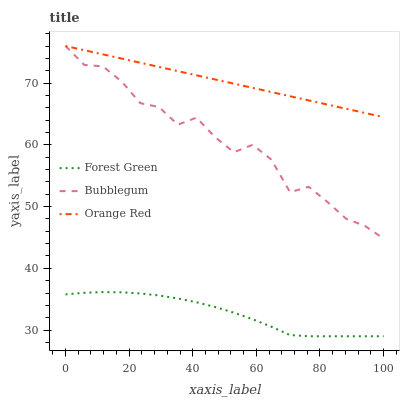Does Forest Green have the minimum area under the curve?
Answer yes or no. Yes. Does Orange Red have the maximum area under the curve?
Answer yes or no. Yes. Does Bubblegum have the minimum area under the curve?
Answer yes or no. No. Does Bubblegum have the maximum area under the curve?
Answer yes or no. No. Is Orange Red the smoothest?
Answer yes or no. Yes. Is Bubblegum the roughest?
Answer yes or no. Yes. Is Bubblegum the smoothest?
Answer yes or no. No. Is Orange Red the roughest?
Answer yes or no. No. Does Forest Green have the lowest value?
Answer yes or no. Yes. Does Bubblegum have the lowest value?
Answer yes or no. No. Does Bubblegum have the highest value?
Answer yes or no. Yes. Is Forest Green less than Bubblegum?
Answer yes or no. Yes. Is Bubblegum greater than Forest Green?
Answer yes or no. Yes. Does Bubblegum intersect Orange Red?
Answer yes or no. Yes. Is Bubblegum less than Orange Red?
Answer yes or no. No. Is Bubblegum greater than Orange Red?
Answer yes or no. No. Does Forest Green intersect Bubblegum?
Answer yes or no. No. 